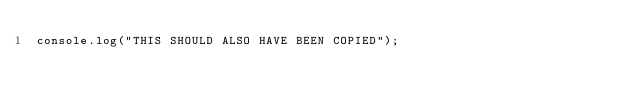Convert code to text. <code><loc_0><loc_0><loc_500><loc_500><_JavaScript_>console.log("THIS SHOULD ALSO HAVE BEEN COPIED");
</code> 